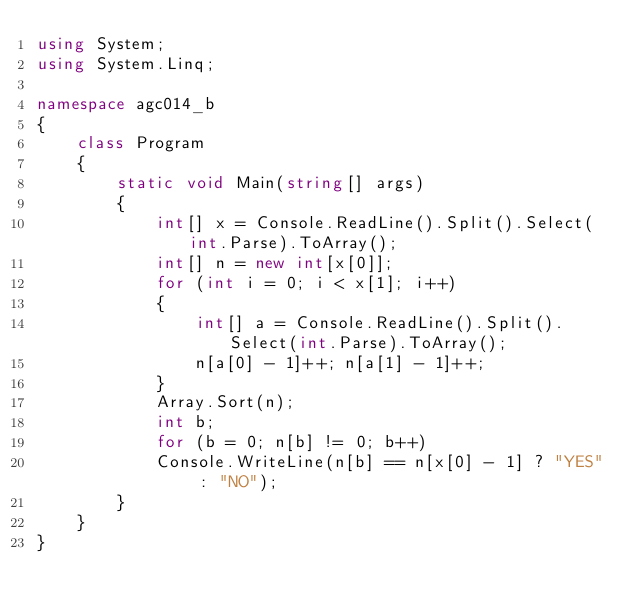Convert code to text. <code><loc_0><loc_0><loc_500><loc_500><_C#_>using System;
using System.Linq;

namespace agc014_b
{
    class Program
    {
        static void Main(string[] args)
        {
            int[] x = Console.ReadLine().Split().Select(int.Parse).ToArray();
            int[] n = new int[x[0]];
            for (int i = 0; i < x[1]; i++)
            {
                int[] a = Console.ReadLine().Split().Select(int.Parse).ToArray();
                n[a[0] - 1]++; n[a[1] - 1]++;
            }
            Array.Sort(n);
            int b;
            for (b = 0; n[b] != 0; b++)
            Console.WriteLine(n[b] == n[x[0] - 1] ? "YES" : "NO");
        }
    }
}</code> 